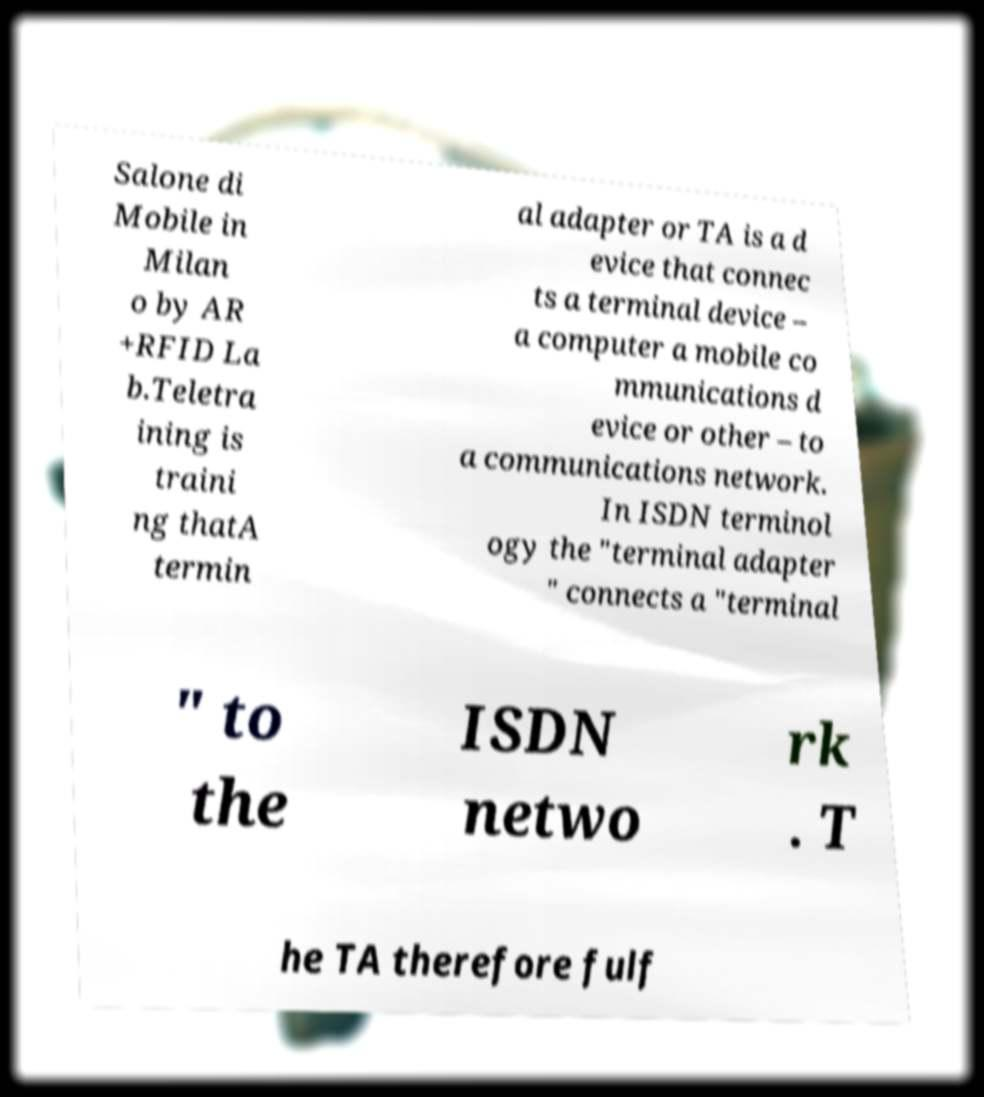Can you read and provide the text displayed in the image?This photo seems to have some interesting text. Can you extract and type it out for me? Salone di Mobile in Milan o by AR +RFID La b.Teletra ining is traini ng thatA termin al adapter or TA is a d evice that connec ts a terminal device – a computer a mobile co mmunications d evice or other – to a communications network. In ISDN terminol ogy the "terminal adapter " connects a "terminal " to the ISDN netwo rk . T he TA therefore fulf 